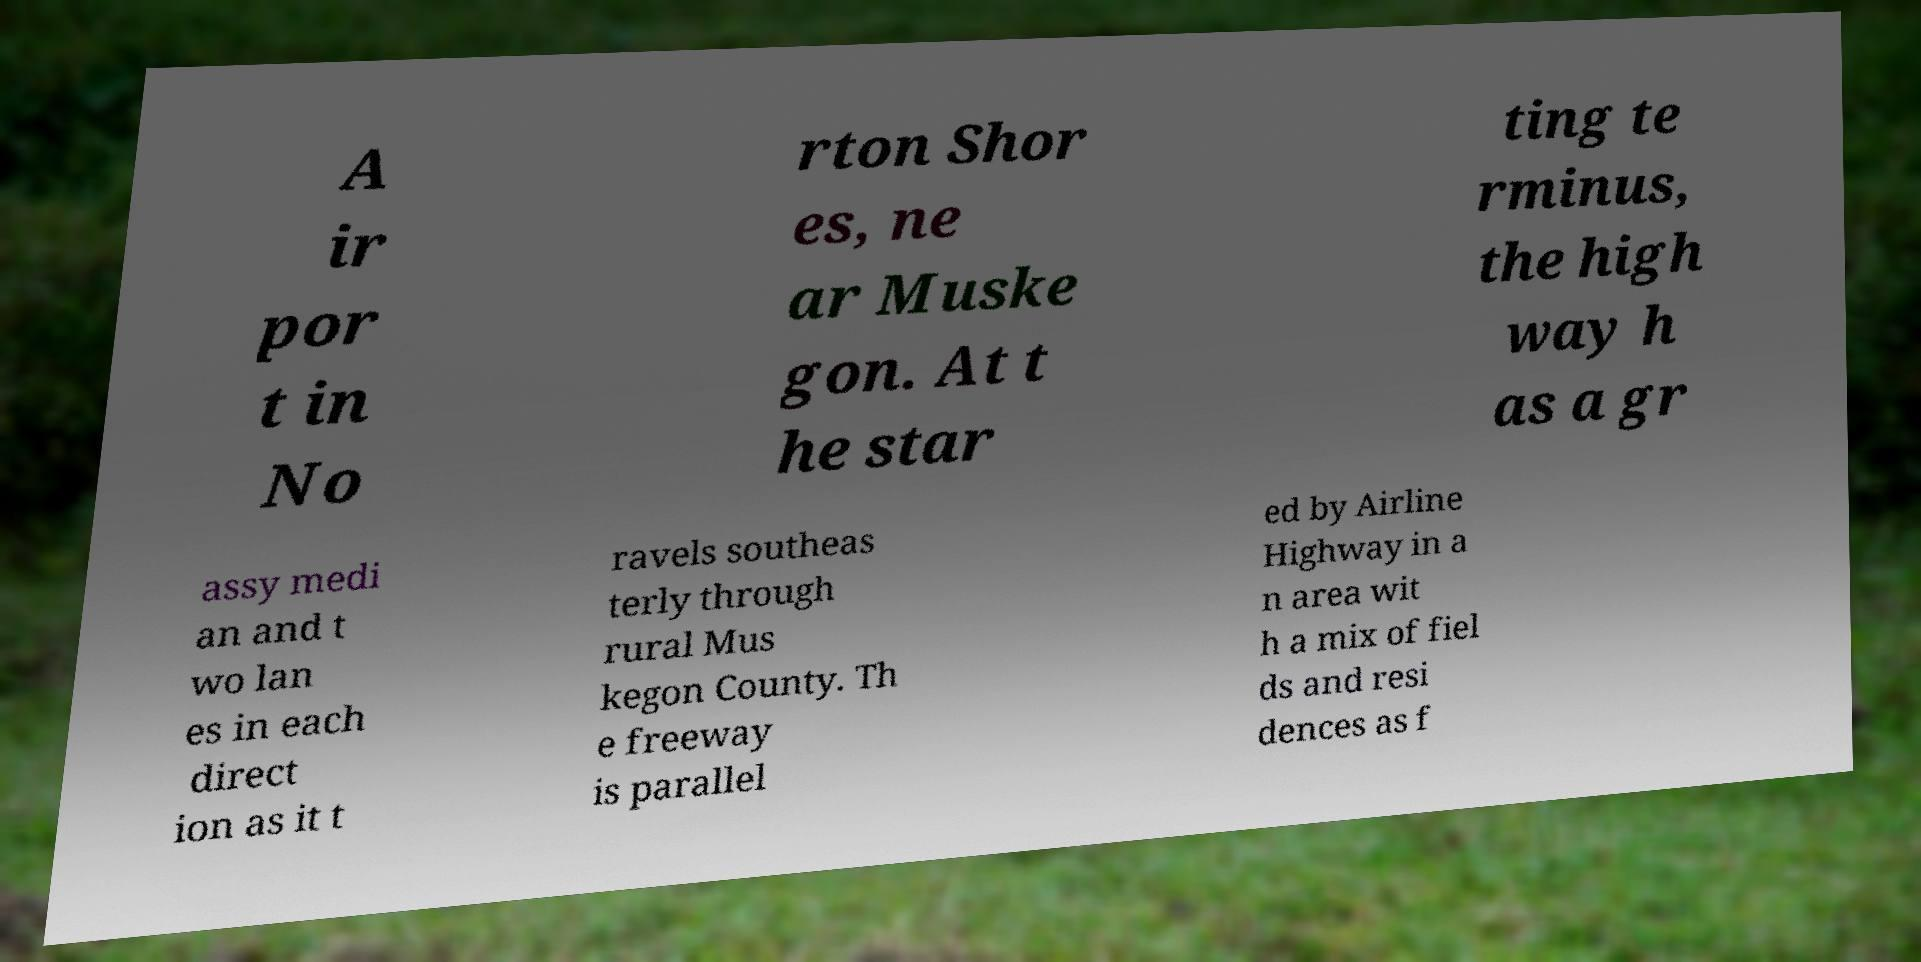Could you extract and type out the text from this image? A ir por t in No rton Shor es, ne ar Muske gon. At t he star ting te rminus, the high way h as a gr assy medi an and t wo lan es in each direct ion as it t ravels southeas terly through rural Mus kegon County. Th e freeway is parallel ed by Airline Highway in a n area wit h a mix of fiel ds and resi dences as f 